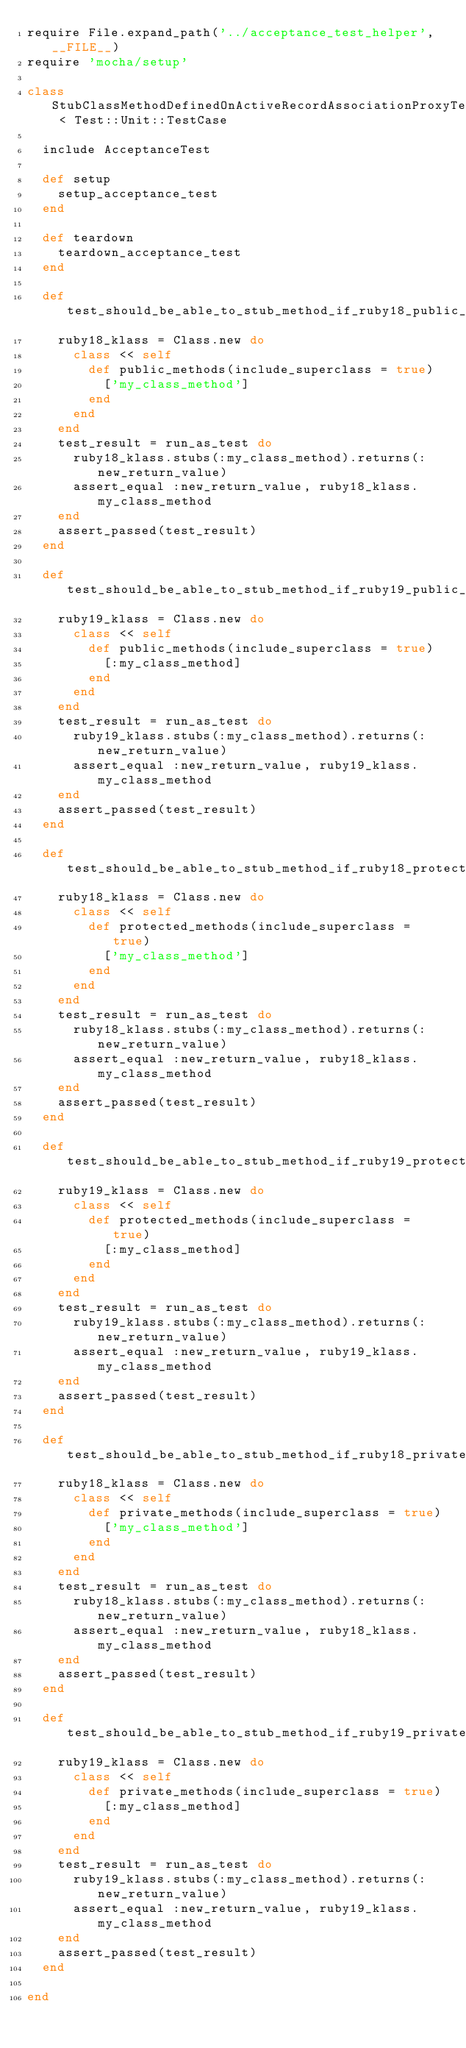Convert code to text. <code><loc_0><loc_0><loc_500><loc_500><_Ruby_>require File.expand_path('../acceptance_test_helper', __FILE__)
require 'mocha/setup'

class StubClassMethodDefinedOnActiveRecordAssociationProxyTest < Test::Unit::TestCase

  include AcceptanceTest

  def setup
    setup_acceptance_test
  end

  def teardown
    teardown_acceptance_test
  end

  def test_should_be_able_to_stub_method_if_ruby18_public_methods_include_method_but_method_does_not_actually_exist_like_active_record_association_proxy
    ruby18_klass = Class.new do
      class << self
        def public_methods(include_superclass = true)
          ['my_class_method']
        end
      end
    end
    test_result = run_as_test do
      ruby18_klass.stubs(:my_class_method).returns(:new_return_value)
      assert_equal :new_return_value, ruby18_klass.my_class_method
    end
    assert_passed(test_result)
  end

  def test_should_be_able_to_stub_method_if_ruby19_public_methods_include_method_but_method_does_not_actually_exist_like_active_record_association_proxy
    ruby19_klass = Class.new do
      class << self
        def public_methods(include_superclass = true)
          [:my_class_method]
        end
      end
    end
    test_result = run_as_test do
      ruby19_klass.stubs(:my_class_method).returns(:new_return_value)
      assert_equal :new_return_value, ruby19_klass.my_class_method
    end
    assert_passed(test_result)
  end

  def test_should_be_able_to_stub_method_if_ruby18_protected_methods_include_method_but_method_does_not_actually_exist_like_active_record_association_proxy
    ruby18_klass = Class.new do
      class << self
        def protected_methods(include_superclass = true)
          ['my_class_method']
        end
      end
    end
    test_result = run_as_test do
      ruby18_klass.stubs(:my_class_method).returns(:new_return_value)
      assert_equal :new_return_value, ruby18_klass.my_class_method
    end
    assert_passed(test_result)
  end

  def test_should_be_able_to_stub_method_if_ruby19_protected_methods_include_method_but_method_does_not_actually_exist_like_active_record_association_proxy
    ruby19_klass = Class.new do
      class << self
        def protected_methods(include_superclass = true)
          [:my_class_method]
        end
      end
    end
    test_result = run_as_test do
      ruby19_klass.stubs(:my_class_method).returns(:new_return_value)
      assert_equal :new_return_value, ruby19_klass.my_class_method
    end
    assert_passed(test_result)
  end

  def test_should_be_able_to_stub_method_if_ruby18_private_methods_include_method_but_method_does_not_actually_exist_like_active_record_association_proxy
    ruby18_klass = Class.new do
      class << self
        def private_methods(include_superclass = true)
          ['my_class_method']
        end
      end
    end
    test_result = run_as_test do
      ruby18_klass.stubs(:my_class_method).returns(:new_return_value)
      assert_equal :new_return_value, ruby18_klass.my_class_method
    end
    assert_passed(test_result)
  end

  def test_should_be_able_to_stub_method_if_ruby19_private_methods_include_method_but_method_does_not_actually_exist_like_active_record_association_proxy
    ruby19_klass = Class.new do
      class << self
        def private_methods(include_superclass = true)
          [:my_class_method]
        end
      end
    end
    test_result = run_as_test do
      ruby19_klass.stubs(:my_class_method).returns(:new_return_value)
      assert_equal :new_return_value, ruby19_klass.my_class_method
    end
    assert_passed(test_result)
  end

end
</code> 